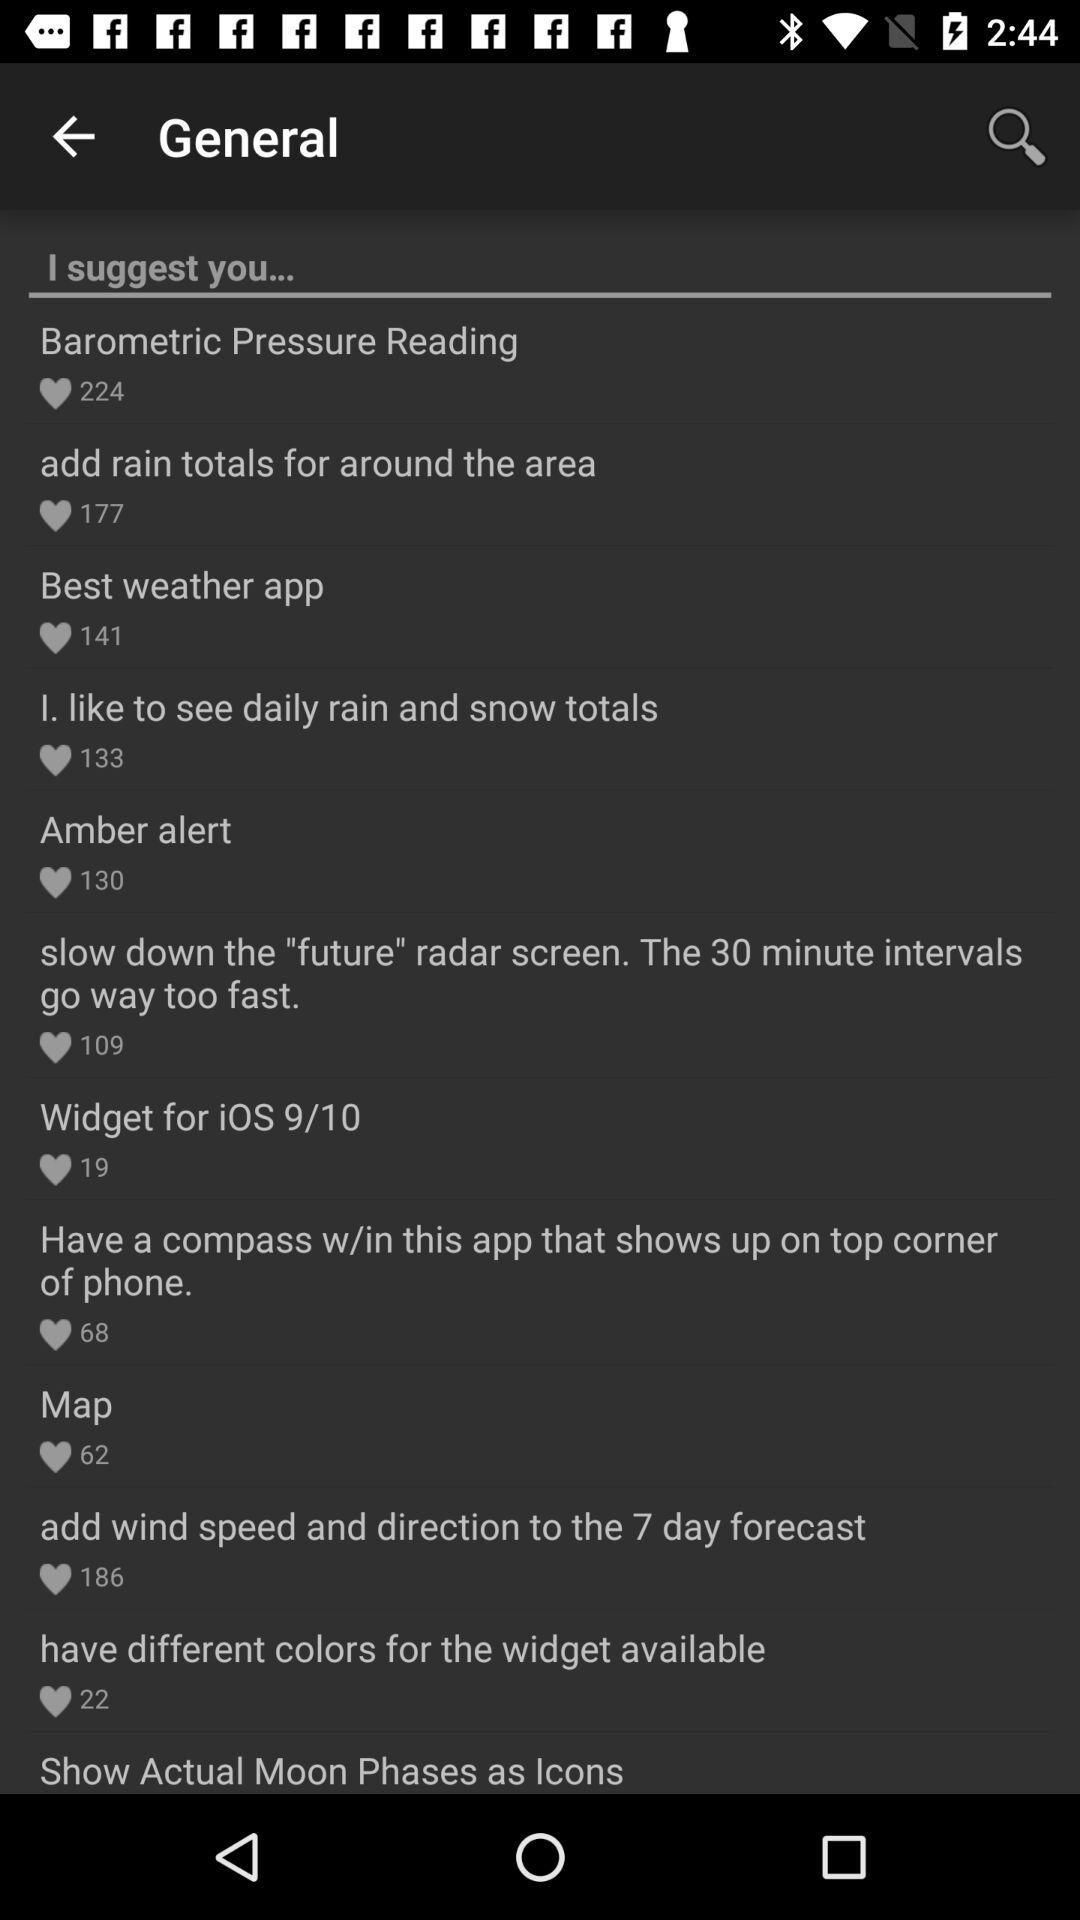What is the number of likes of the "Best weather app"? The number of likes is 141. 